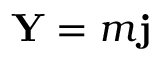<formula> <loc_0><loc_0><loc_500><loc_500>Y = m j</formula> 